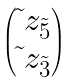<formula> <loc_0><loc_0><loc_500><loc_500>\begin{pmatrix} \tilde { \ } z _ { \tilde { 5 } } \\ \tilde { \ } z _ { \tilde { 3 } } \end{pmatrix}</formula> 